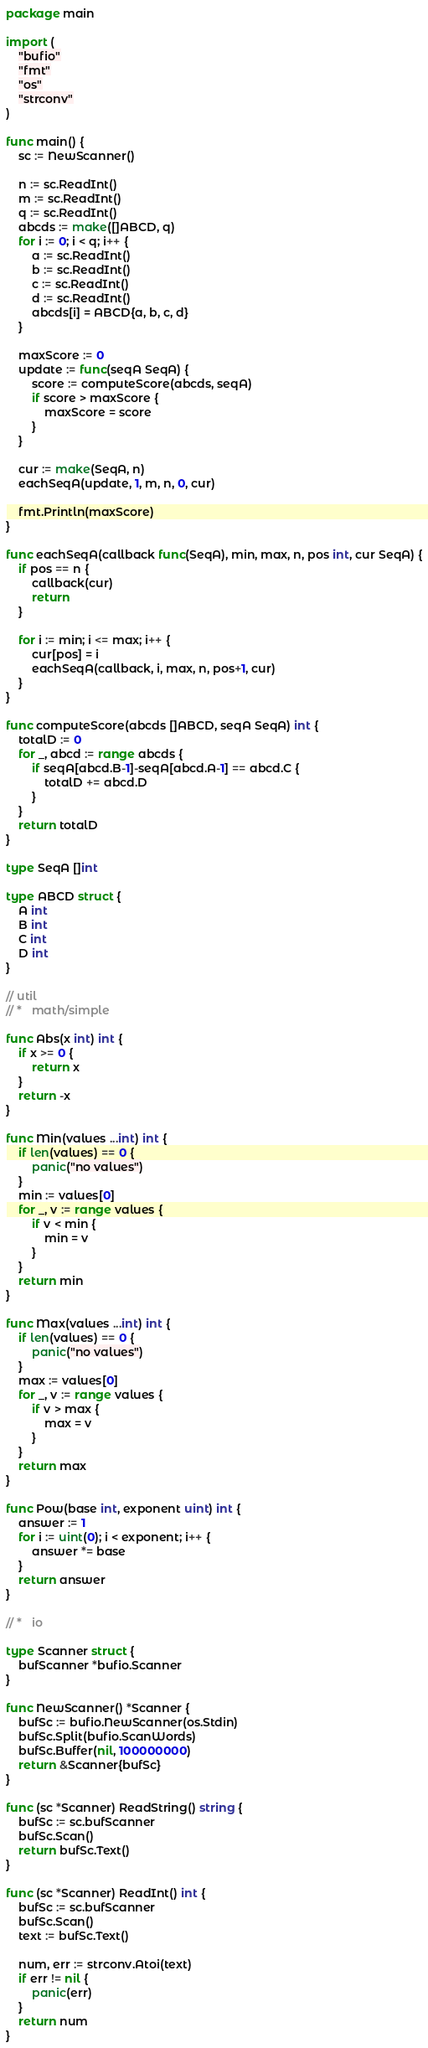Convert code to text. <code><loc_0><loc_0><loc_500><loc_500><_Go_>package main

import (
	"bufio"
	"fmt"
	"os"
	"strconv"
)

func main() {
	sc := NewScanner()

	n := sc.ReadInt()
	m := sc.ReadInt()
	q := sc.ReadInt()
	abcds := make([]ABCD, q)
	for i := 0; i < q; i++ {
		a := sc.ReadInt()
		b := sc.ReadInt()
		c := sc.ReadInt()
		d := sc.ReadInt()
		abcds[i] = ABCD{a, b, c, d}
	}

	maxScore := 0
	update := func(seqA SeqA) {
		score := computeScore(abcds, seqA)
		if score > maxScore {
			maxScore = score
		}
	}

	cur := make(SeqA, n)
	eachSeqA(update, 1, m, n, 0, cur)

	fmt.Println(maxScore)
}

func eachSeqA(callback func(SeqA), min, max, n, pos int, cur SeqA) {
	if pos == n {
		callback(cur)
		return
	}

	for i := min; i <= max; i++ {
		cur[pos] = i
		eachSeqA(callback, i, max, n, pos+1, cur)
	}
}

func computeScore(abcds []ABCD, seqA SeqA) int {
	totalD := 0
	for _, abcd := range abcds {
		if seqA[abcd.B-1]-seqA[abcd.A-1] == abcd.C {
			totalD += abcd.D
		}
	}
	return totalD
}

type SeqA []int

type ABCD struct {
	A int
	B int
	C int
	D int
}

// util
// *   math/simple

func Abs(x int) int {
	if x >= 0 {
		return x
	}
	return -x
}

func Min(values ...int) int {
	if len(values) == 0 {
		panic("no values")
	}
	min := values[0]
	for _, v := range values {
		if v < min {
			min = v
		}
	}
	return min
}

func Max(values ...int) int {
	if len(values) == 0 {
		panic("no values")
	}
	max := values[0]
	for _, v := range values {
		if v > max {
			max = v
		}
	}
	return max
}

func Pow(base int, exponent uint) int {
	answer := 1
	for i := uint(0); i < exponent; i++ {
		answer *= base
	}
	return answer
}

// *   io

type Scanner struct {
	bufScanner *bufio.Scanner
}

func NewScanner() *Scanner {
	bufSc := bufio.NewScanner(os.Stdin)
	bufSc.Split(bufio.ScanWords)
	bufSc.Buffer(nil, 100000000)
	return &Scanner{bufSc}
}

func (sc *Scanner) ReadString() string {
	bufSc := sc.bufScanner
	bufSc.Scan()
	return bufSc.Text()
}

func (sc *Scanner) ReadInt() int {
	bufSc := sc.bufScanner
	bufSc.Scan()
	text := bufSc.Text()

	num, err := strconv.Atoi(text)
	if err != nil {
		panic(err)
	}
	return num
}
</code> 